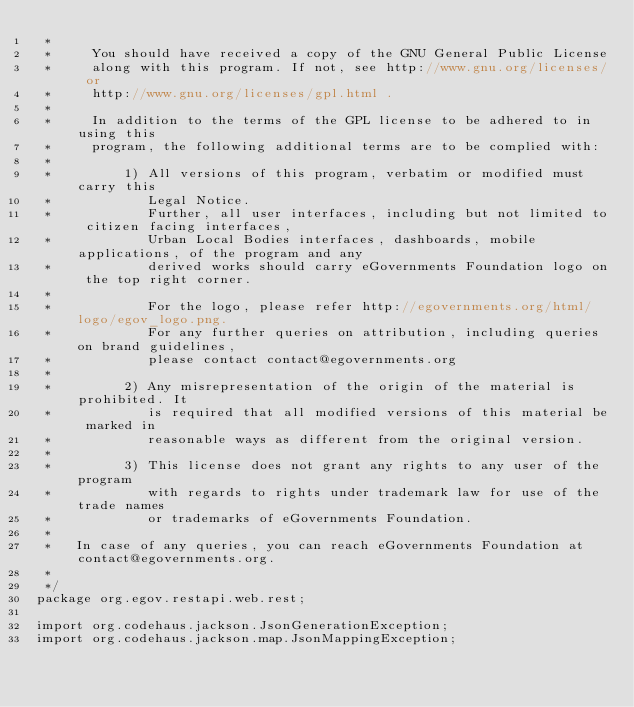Convert code to text. <code><loc_0><loc_0><loc_500><loc_500><_Java_> *
 *     You should have received a copy of the GNU General Public License
 *     along with this program. If not, see http://www.gnu.org/licenses/ or
 *     http://www.gnu.org/licenses/gpl.html .
 *
 *     In addition to the terms of the GPL license to be adhered to in using this
 *     program, the following additional terms are to be complied with:
 *
 *         1) All versions of this program, verbatim or modified must carry this
 *            Legal Notice.
 *            Further, all user interfaces, including but not limited to citizen facing interfaces,
 *            Urban Local Bodies interfaces, dashboards, mobile applications, of the program and any
 *            derived works should carry eGovernments Foundation logo on the top right corner.
 *
 *            For the logo, please refer http://egovernments.org/html/logo/egov_logo.png.
 *            For any further queries on attribution, including queries on brand guidelines,
 *            please contact contact@egovernments.org
 *
 *         2) Any misrepresentation of the origin of the material is prohibited. It
 *            is required that all modified versions of this material be marked in
 *            reasonable ways as different from the original version.
 *
 *         3) This license does not grant any rights to any user of the program
 *            with regards to rights under trademark law for use of the trade names
 *            or trademarks of eGovernments Foundation.
 *
 *   In case of any queries, you can reach eGovernments Foundation at contact@egovernments.org.
 *
 */
package org.egov.restapi.web.rest;

import org.codehaus.jackson.JsonGenerationException;
import org.codehaus.jackson.map.JsonMappingException;</code> 